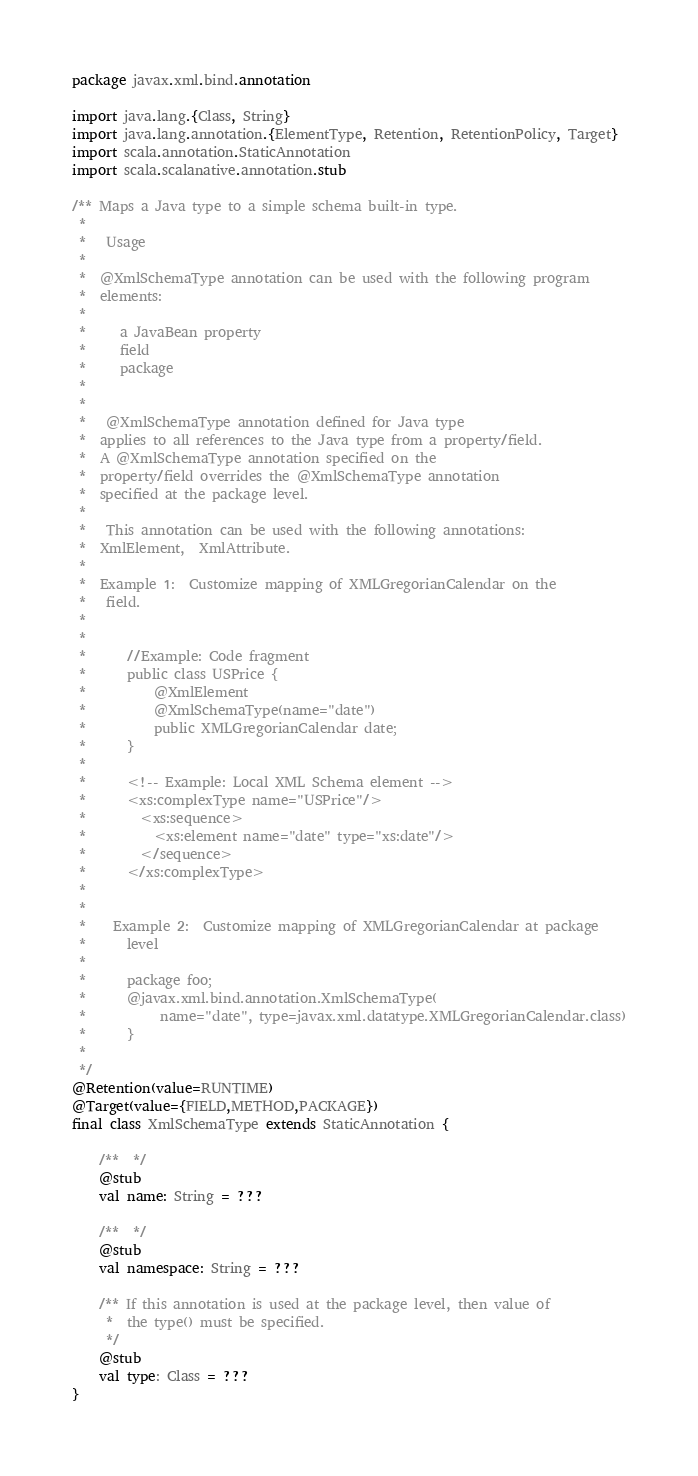Convert code to text. <code><loc_0><loc_0><loc_500><loc_500><_Scala_>package javax.xml.bind.annotation

import java.lang.{Class, String}
import java.lang.annotation.{ElementType, Retention, RetentionPolicy, Target}
import scala.annotation.StaticAnnotation
import scala.scalanative.annotation.stub

/** Maps a Java type to a simple schema built-in type.
 * 
 *   Usage 
 *  
 *  @XmlSchemaType annotation can be used with the following program
 *  elements:
 *  
 *     a JavaBean property 
 *     field 
 *     package
 *  
 * 
 *   @XmlSchemaType annotation defined for Java type
 *  applies to all references to the Java type from a property/field.
 *  A @XmlSchemaType annotation specified on the
 *  property/field overrides the @XmlSchemaType annotation
 *  specified at the package level.
 * 
 *   This annotation can be used with the following annotations:
 *  XmlElement,  XmlAttribute.
 *  
 *  Example 1:  Customize mapping of XMLGregorianCalendar on the
 *   field.
 * 
 *  
 *      //Example: Code fragment
 *      public class USPrice {
 *          @XmlElement
 *          @XmlSchemaType(name="date")
 *          public XMLGregorianCalendar date;
 *      }
 * 
 *      <!-- Example: Local XML Schema element -->
 *      <xs:complexType name="USPrice"/>
 *        <xs:sequence>
 *          <xs:element name="date" type="xs:date"/>
 *        </sequence>
 *      </xs:complexType>
 *  
 * 
 *    Example 2:  Customize mapping of XMLGregorianCalendar at package
 *      level 
 *  
 *      package foo;
 *      @javax.xml.bind.annotation.XmlSchemaType(
 *           name="date", type=javax.xml.datatype.XMLGregorianCalendar.class)
 *      }
 *  
 */
@Retention(value=RUNTIME)
@Target(value={FIELD,METHOD,PACKAGE})
final class XmlSchemaType extends StaticAnnotation {

    /**  */
    @stub
    val name: String = ???

    /**  */
    @stub
    val namespace: String = ???

    /** If this annotation is used at the package level, then value of
     *  the type() must be specified.
     */
    @stub
    val type: Class = ???
}
</code> 